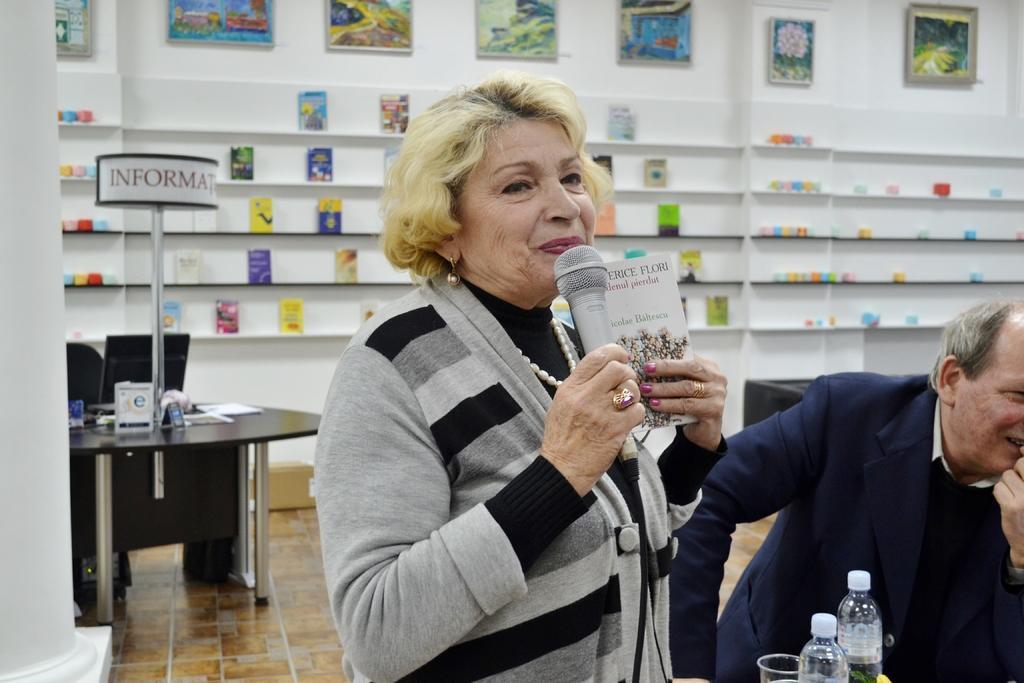In one or two sentences, can you explain what this image depicts? In this image there is a person standing and holding a book and a mike, and there is another person, water bottles,glass, table, chair, monitor, books on the racks, frames attached to the wall. 